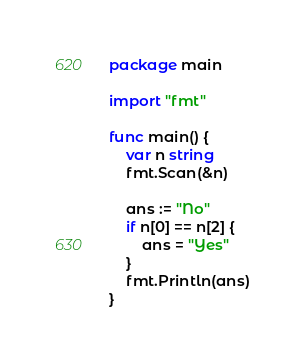Convert code to text. <code><loc_0><loc_0><loc_500><loc_500><_Go_>package main

import "fmt"

func main() {
	var n string
	fmt.Scan(&n)

	ans := "No"
	if n[0] == n[2] {
		ans = "Yes"
	}
	fmt.Println(ans)
}
</code> 